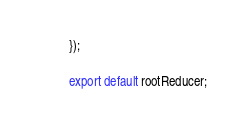<code> <loc_0><loc_0><loc_500><loc_500><_JavaScript_>});

export default rootReducer;
</code> 